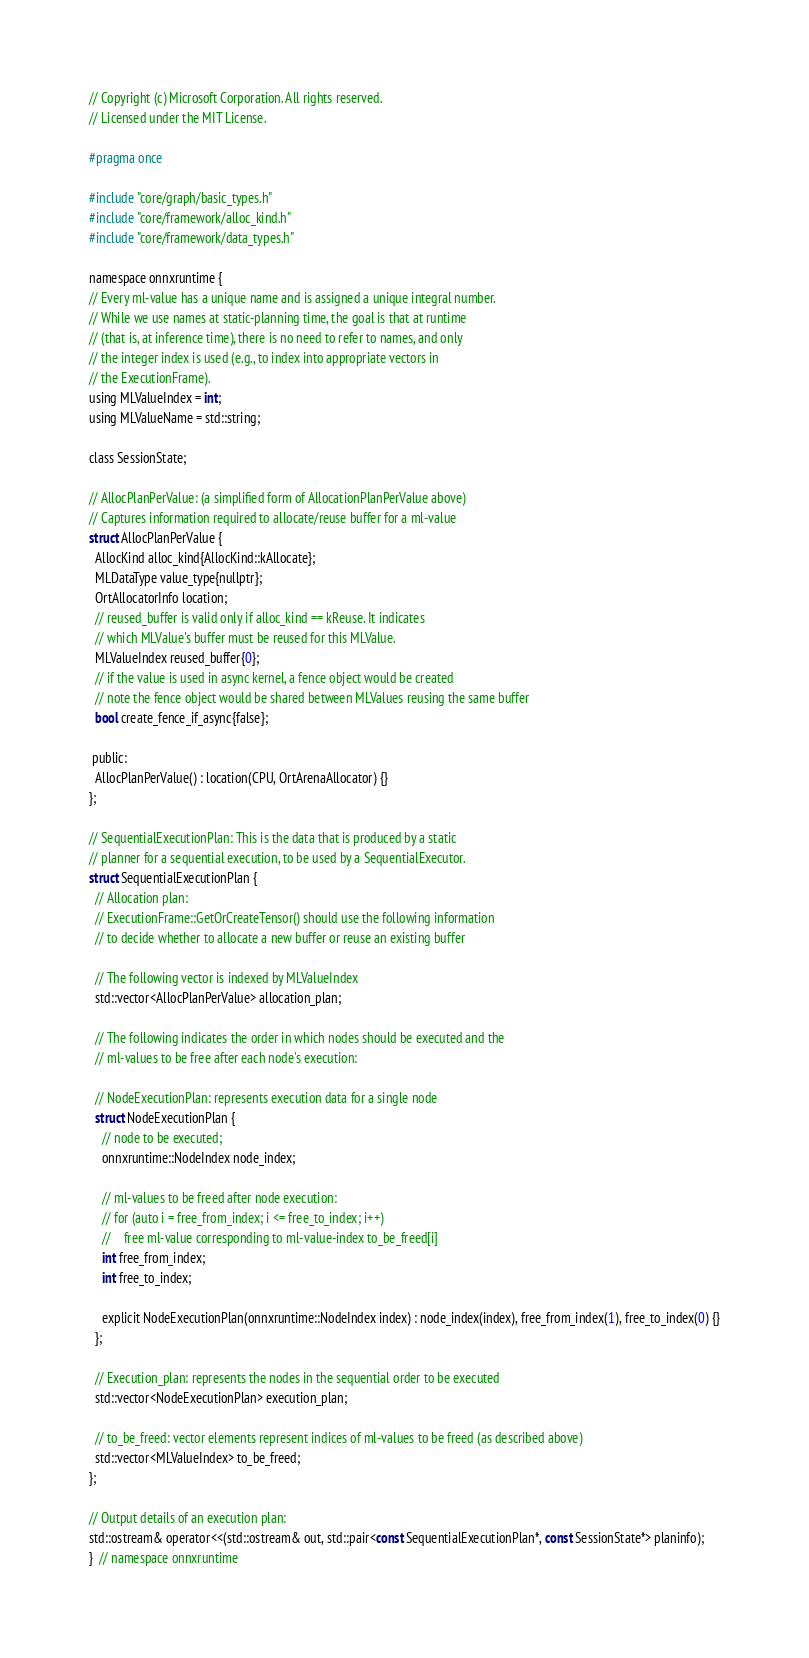<code> <loc_0><loc_0><loc_500><loc_500><_C_>// Copyright (c) Microsoft Corporation. All rights reserved.
// Licensed under the MIT License.

#pragma once

#include "core/graph/basic_types.h"
#include "core/framework/alloc_kind.h"
#include "core/framework/data_types.h"

namespace onnxruntime {
// Every ml-value has a unique name and is assigned a unique integral number.
// While we use names at static-planning time, the goal is that at runtime
// (that is, at inference time), there is no need to refer to names, and only
// the integer index is used (e.g., to index into appropriate vectors in
// the ExecutionFrame).
using MLValueIndex = int;
using MLValueName = std::string;

class SessionState;

// AllocPlanPerValue: (a simplified form of AllocationPlanPerValue above)
// Captures information required to allocate/reuse buffer for a ml-value
struct AllocPlanPerValue {
  AllocKind alloc_kind{AllocKind::kAllocate};
  MLDataType value_type{nullptr};
  OrtAllocatorInfo location;
  // reused_buffer is valid only if alloc_kind == kReuse. It indicates
  // which MLValue's buffer must be reused for this MLValue.
  MLValueIndex reused_buffer{0};
  // if the value is used in async kernel, a fence object would be created
  // note the fence object would be shared between MLValues reusing the same buffer
  bool create_fence_if_async{false};

 public:
  AllocPlanPerValue() : location(CPU, OrtArenaAllocator) {}
};

// SequentialExecutionPlan: This is the data that is produced by a static
// planner for a sequential execution, to be used by a SequentialExecutor.
struct SequentialExecutionPlan {
  // Allocation plan:
  // ExecutionFrame::GetOrCreateTensor() should use the following information
  // to decide whether to allocate a new buffer or reuse an existing buffer

  // The following vector is indexed by MLValueIndex
  std::vector<AllocPlanPerValue> allocation_plan;

  // The following indicates the order in which nodes should be executed and the
  // ml-values to be free after each node's execution:

  // NodeExecutionPlan: represents execution data for a single node
  struct NodeExecutionPlan {
    // node to be executed;
    onnxruntime::NodeIndex node_index;

    // ml-values to be freed after node execution:
    // for (auto i = free_from_index; i <= free_to_index; i++)
    //    free ml-value corresponding to ml-value-index to_be_freed[i]
    int free_from_index;
    int free_to_index;

    explicit NodeExecutionPlan(onnxruntime::NodeIndex index) : node_index(index), free_from_index(1), free_to_index(0) {}
  };

  // Execution_plan: represents the nodes in the sequential order to be executed
  std::vector<NodeExecutionPlan> execution_plan;

  // to_be_freed: vector elements represent indices of ml-values to be freed (as described above)
  std::vector<MLValueIndex> to_be_freed;
};

// Output details of an execution plan:
std::ostream& operator<<(std::ostream& out, std::pair<const SequentialExecutionPlan*, const SessionState*> planinfo);
}  // namespace onnxruntime
</code> 